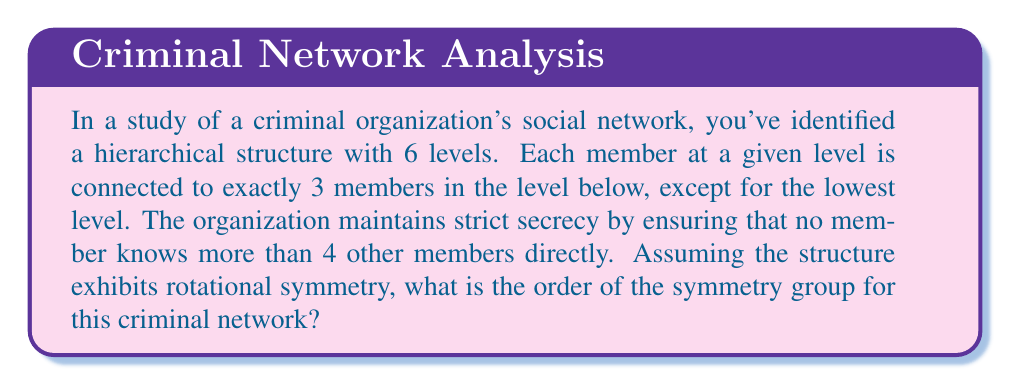What is the answer to this math problem? To solve this problem, we need to analyze the structure of the criminal organization and determine its symmetry properties. Let's approach this step-by-step:

1) First, let's visualize the structure:
   - 1 member at the top level
   - 3 members at the second level
   - 9 members at the third level
   - 27 members at the fourth level
   - 81 members at the fifth level
   - 243 members at the sixth level

2) The total number of members is:
   $$ 1 + 3 + 9 + 27 + 81 + 243 = 364 $$

3) The structure has rotational symmetry. Each member (except those at the bottom) is connected to 3 members below, creating a 3-fold rotational symmetry.

4) The symmetry group of this structure is isomorphic to the cyclic group $C_3$, as it can be rotated by 120° and 240° to produce identical configurations.

5) The order of a cyclic group is equal to the number of elements in the group. In this case, there are 3 possible rotations (including the identity rotation), so the order of the symmetry group is 3.

6) It's worth noting that while the network has 364 members, the symmetry group's order is independent of the total number of members. It depends on the rotational symmetry of the structure.

7) The secrecy condition (no member knows more than 4 others directly) is satisfied in this structure:
   - Top level member knows 3 below
   - Second level members know 1 above and 3 below
   - Third level and below know 1 above and 3 below (or fewer for the bottom level)
Answer: The order of the symmetry group for this criminal network is 3. 